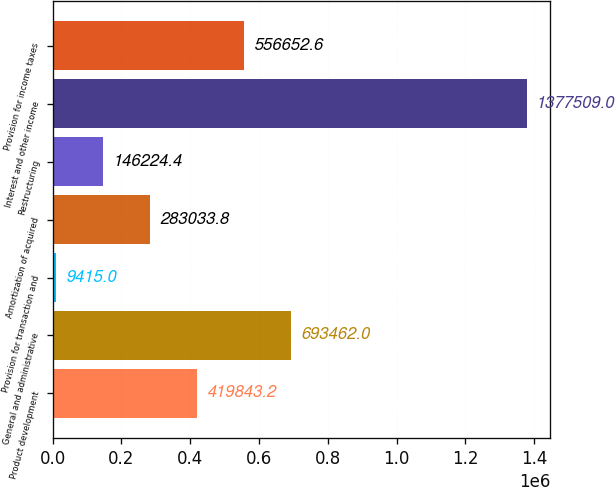<chart> <loc_0><loc_0><loc_500><loc_500><bar_chart><fcel>Product development<fcel>General and administrative<fcel>Provision for transaction and<fcel>Amortization of acquired<fcel>Restructuring<fcel>Interest and other income<fcel>Provision for income taxes<nl><fcel>419843<fcel>693462<fcel>9415<fcel>283034<fcel>146224<fcel>1.37751e+06<fcel>556653<nl></chart> 